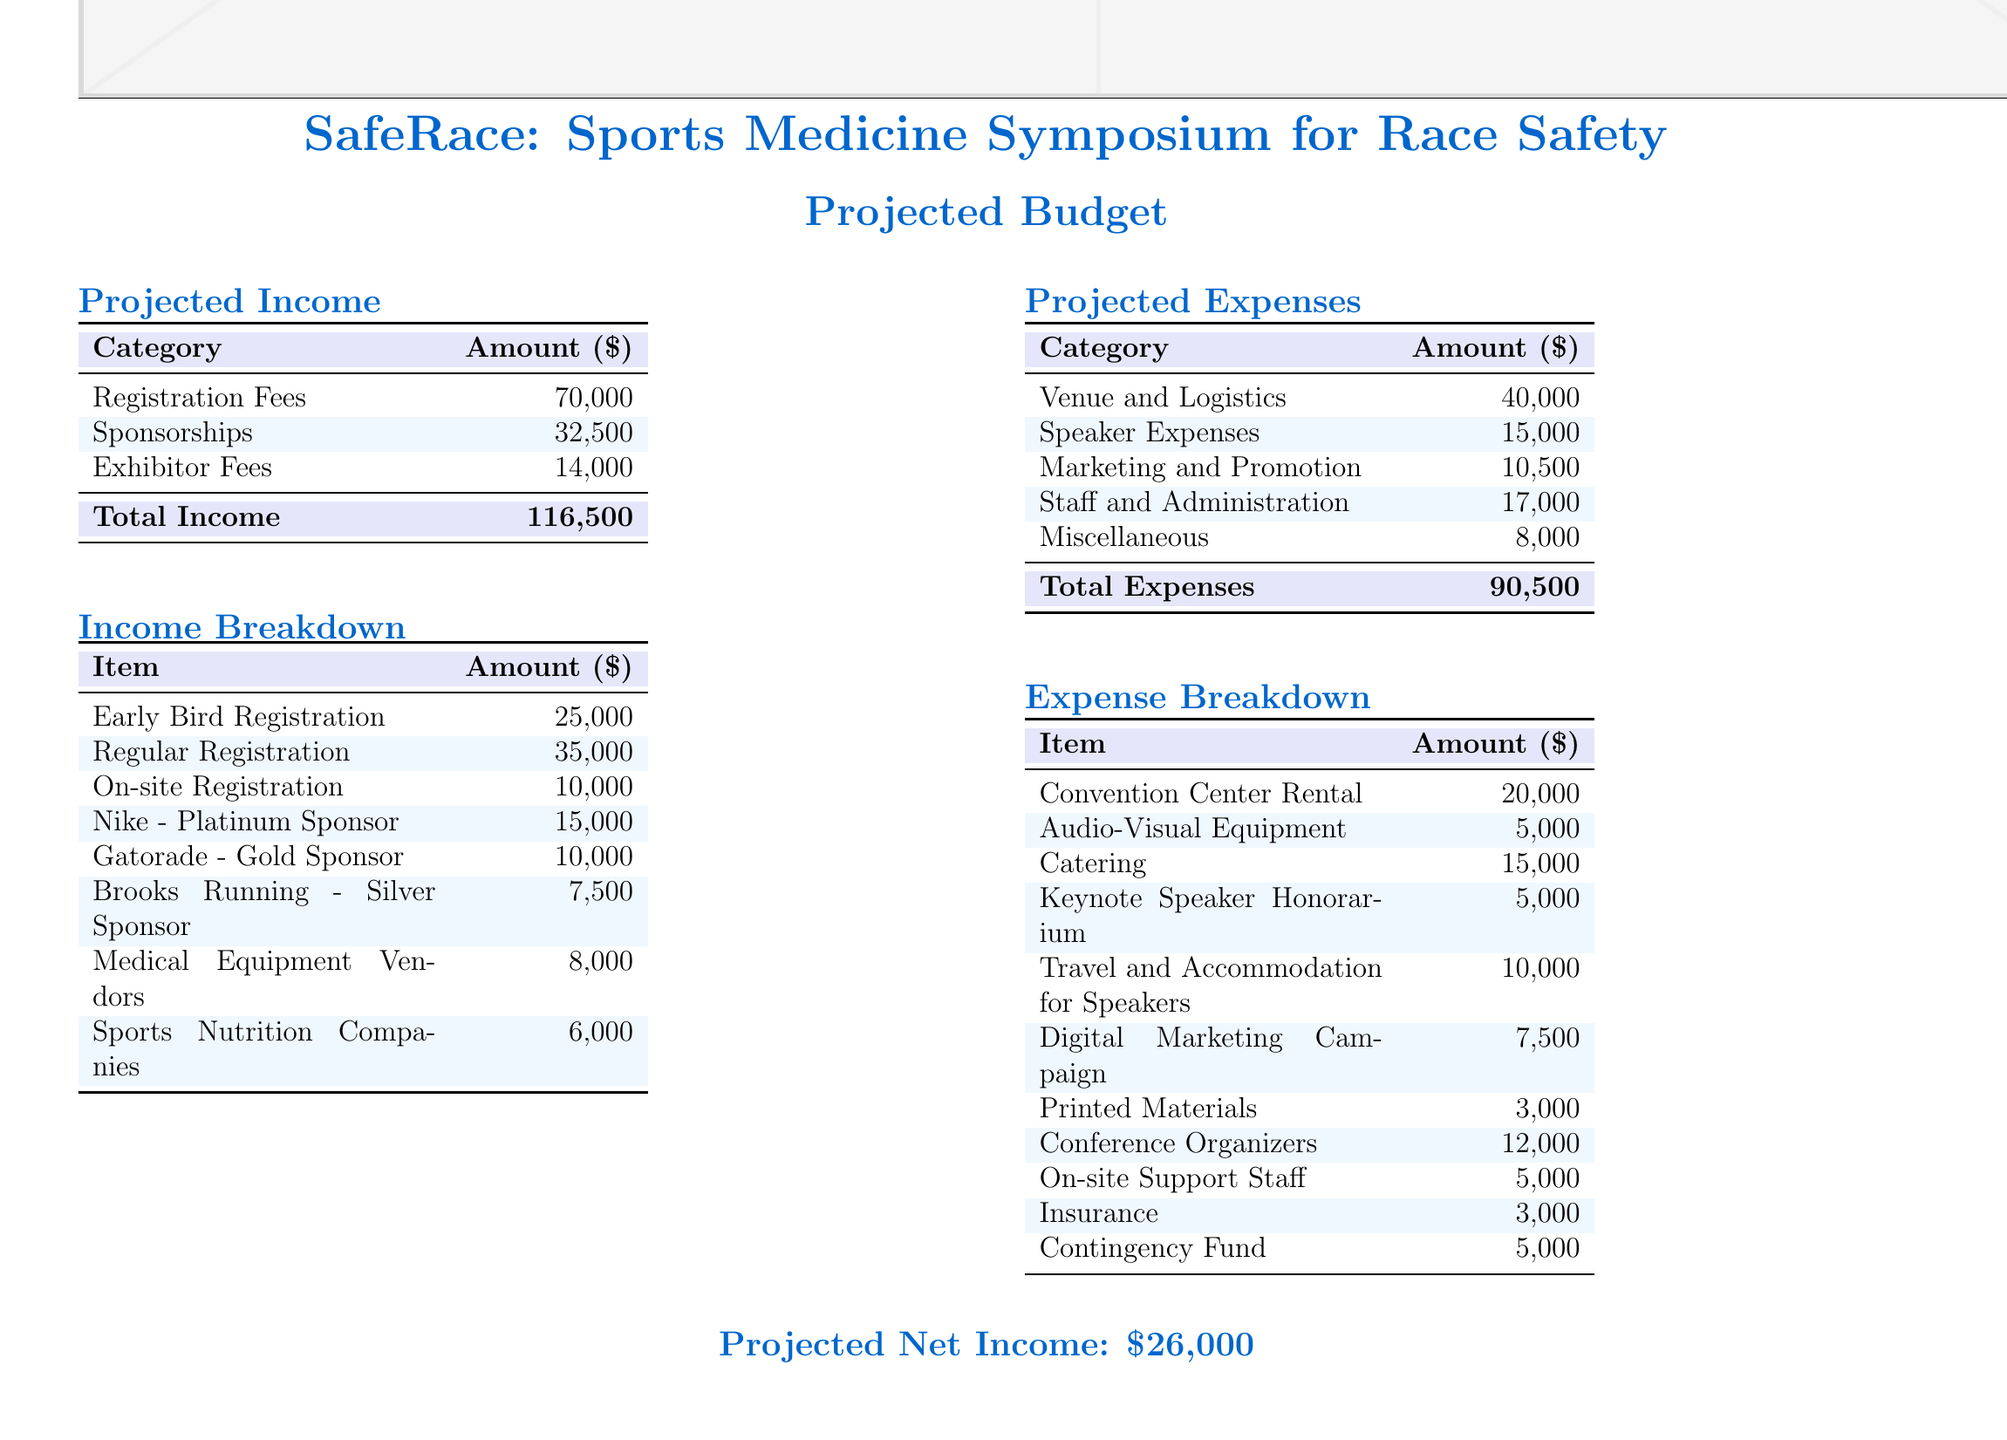What is the total projected income? The total projected income is listed as the sum of all income sources, which are Registration Fees, Sponsorships, and Exhibitor Fees.
Answer: 116,500 What is the amount for Speaker Expenses? The amount for Speaker Expenses is specifically mentioned under the Projected Expenses section.
Answer: 15,000 What is the breakdown of Early Bird Registration? Early Bird Registration is part of the Income Breakdown section, which specifies its total amount.
Answer: 25,000 What is the total projected expenses? The total projected expenses are calculated by summing up all expenses listed in the document.
Answer: 90,500 What are the total net income projections? The total net income is obtained by subtracting total expenses from total income.
Answer: 26,000 Which category has the highest income? The income category can be determined from the Income Breakdown table where each source is listed.
Answer: Registration Fees What is the amount allocated for the venue and logistics? This amount is stated in the Projected Expenses section under the Venue and Logistics category.
Answer: 40,000 How much is allocated for insurance? The amount for insurance is found in the Expense Breakdown section.
Answer: 3,000 What is the anticipated income from sponsorships? The anticipated income from sponsorships is specifically mentioned under the Projected Income section.
Answer: 32,500 